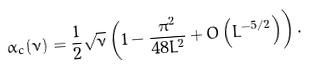Convert formula to latex. <formula><loc_0><loc_0><loc_500><loc_500>\alpha _ { c } ( \nu ) = \frac { 1 } { 2 } \sqrt { \nu } \left ( 1 - \frac { \pi ^ { 2 } } { 4 8 L ^ { 2 } } + O \left ( L ^ { - 5 / 2 } \right ) \right ) .</formula> 